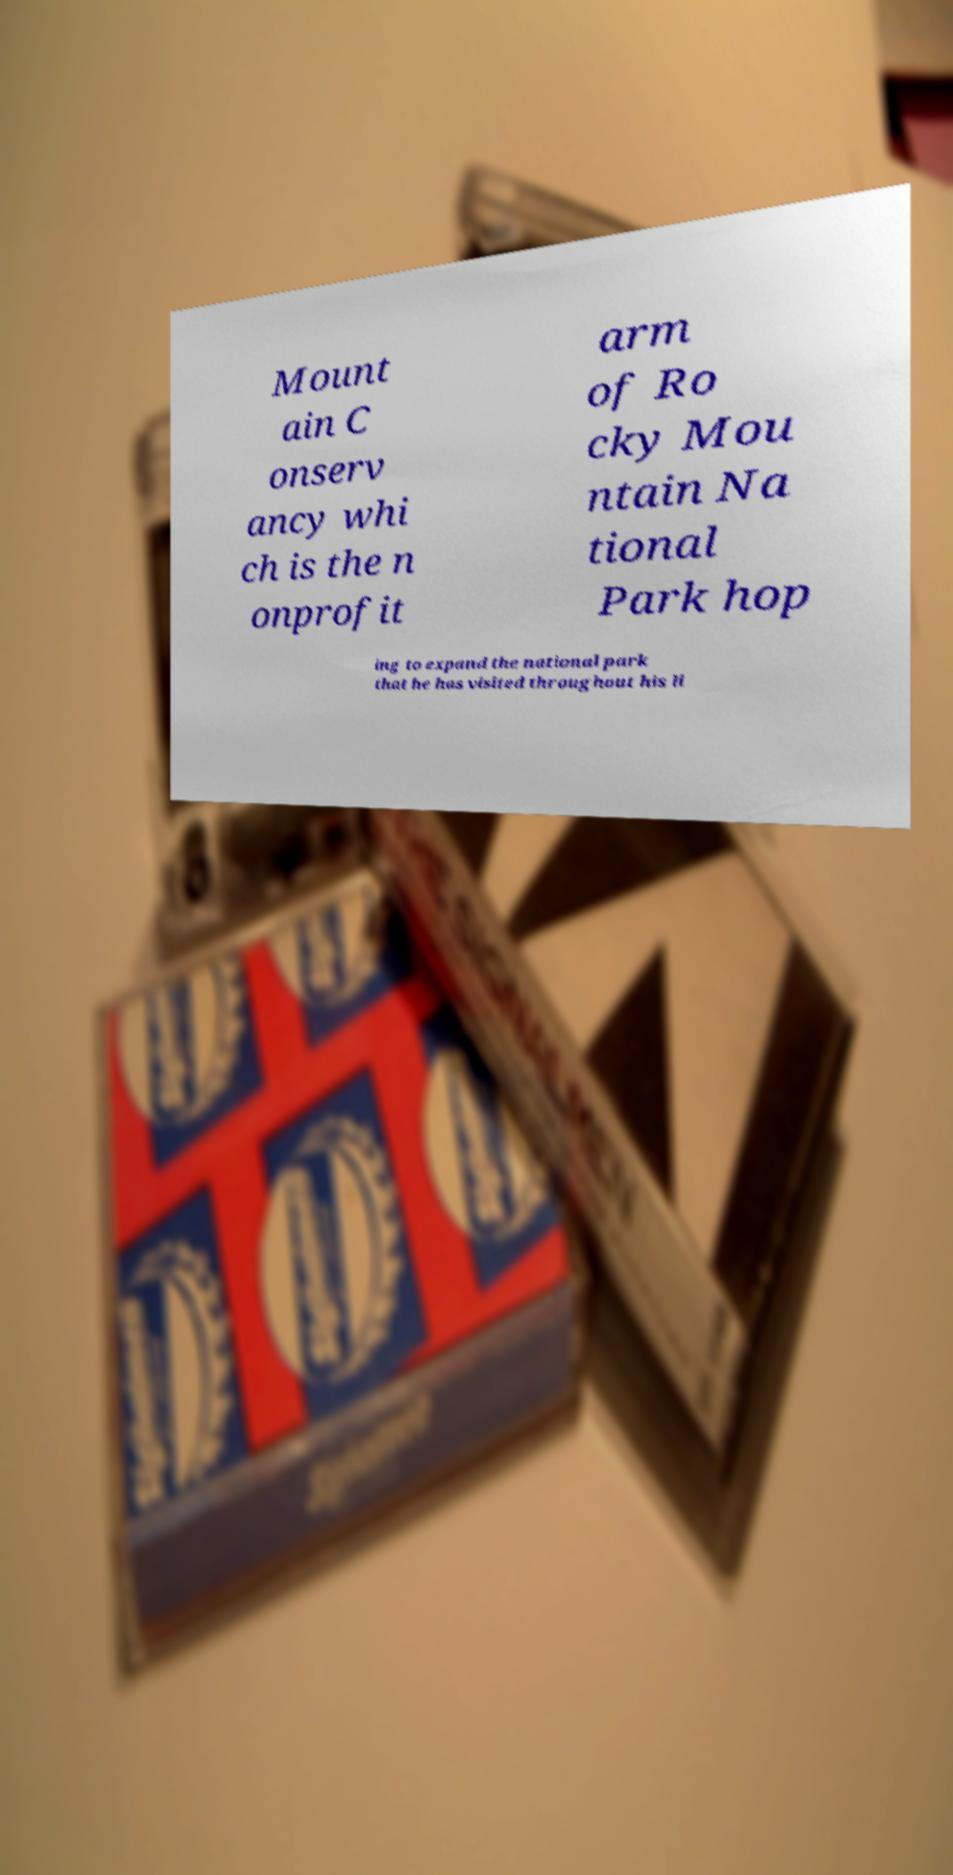What messages or text are displayed in this image? I need them in a readable, typed format. Mount ain C onserv ancy whi ch is the n onprofit arm of Ro cky Mou ntain Na tional Park hop ing to expand the national park that he has visited throughout his li 